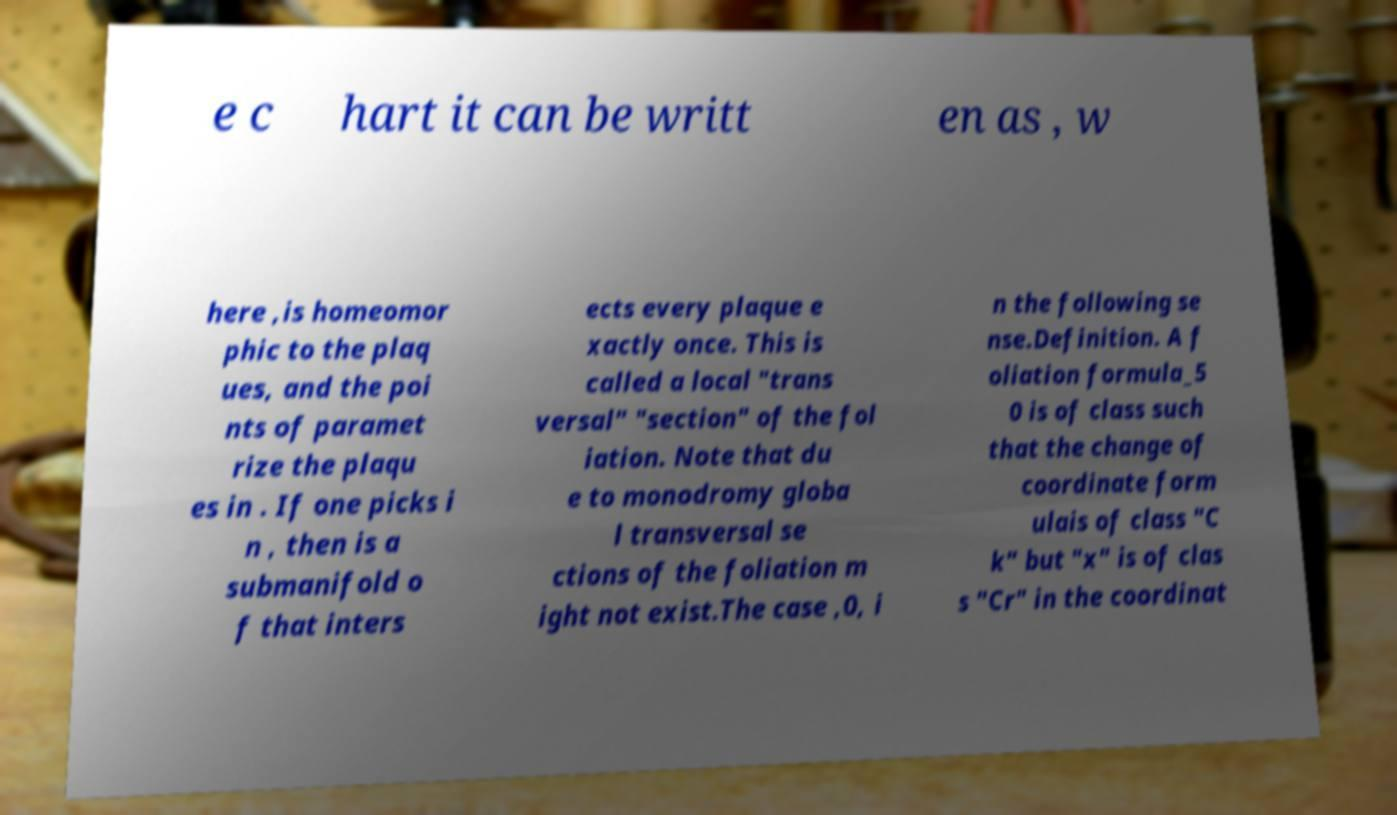For documentation purposes, I need the text within this image transcribed. Could you provide that? e c hart it can be writt en as , w here ,is homeomor phic to the plaq ues, and the poi nts of paramet rize the plaqu es in . If one picks i n , then is a submanifold o f that inters ects every plaque e xactly once. This is called a local "trans versal" "section" of the fol iation. Note that du e to monodromy globa l transversal se ctions of the foliation m ight not exist.The case ,0, i n the following se nse.Definition. A f oliation formula_5 0 is of class such that the change of coordinate form ulais of class "C k" but "x" is of clas s "Cr" in the coordinat 